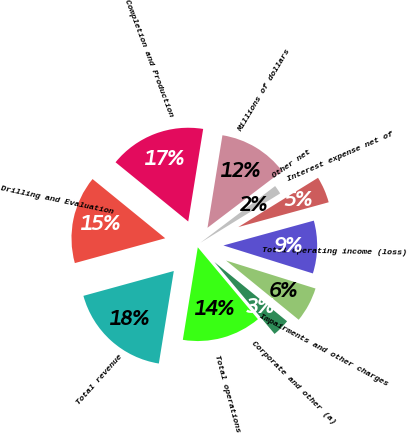Convert chart to OTSL. <chart><loc_0><loc_0><loc_500><loc_500><pie_chart><fcel>Millions of dollars<fcel>Completion and Production<fcel>Drilling and Evaluation<fcel>Total revenue<fcel>Total operations<fcel>Corporate and other (a)<fcel>Impairments and other charges<fcel>Total operating income (loss)<fcel>Interest expense net of<fcel>Other net<nl><fcel>12.12%<fcel>16.67%<fcel>15.15%<fcel>18.18%<fcel>13.64%<fcel>3.03%<fcel>6.06%<fcel>9.09%<fcel>4.55%<fcel>1.52%<nl></chart> 